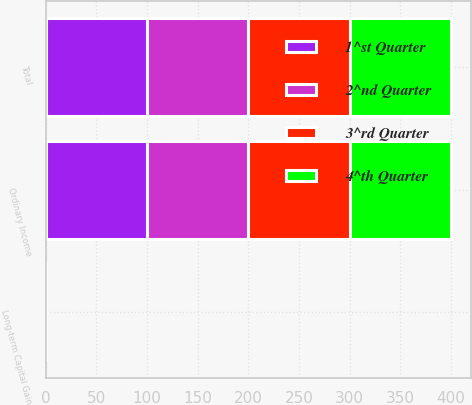Convert chart. <chart><loc_0><loc_0><loc_500><loc_500><stacked_bar_chart><ecel><fcel>Ordinary Income<fcel>Long-term Capital Gain<fcel>Total<nl><fcel>4^th Quarter<fcel>100<fcel>0<fcel>100<nl><fcel>3^rd Quarter<fcel>100<fcel>0<fcel>100<nl><fcel>1^st Quarter<fcel>100<fcel>0<fcel>100<nl><fcel>2^nd Quarter<fcel>100<fcel>0<fcel>100<nl></chart> 